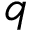Convert formula to latex. <formula><loc_0><loc_0><loc_500><loc_500>q</formula> 